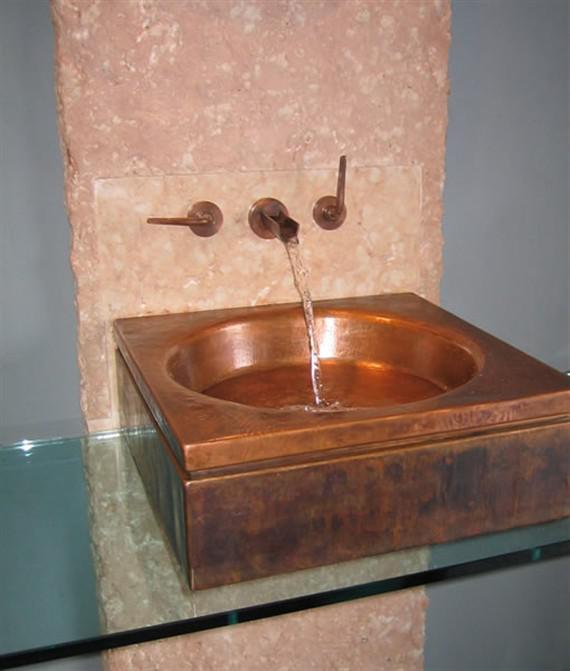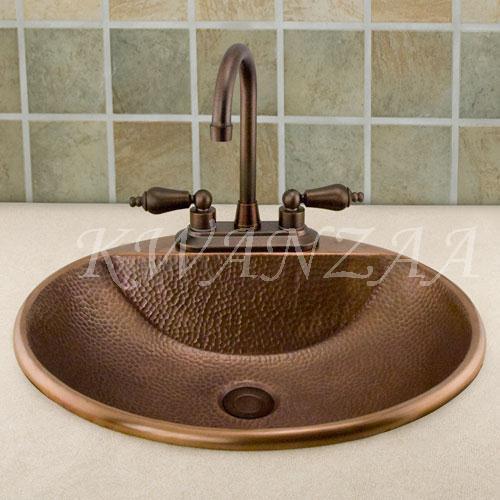The first image is the image on the left, the second image is the image on the right. Considering the images on both sides, is "Water is coming out of one of the faucets." valid? Answer yes or no. Yes. The first image is the image on the left, the second image is the image on the right. For the images displayed, is the sentence "Water is running from a faucet in one of the images." factually correct? Answer yes or no. Yes. 